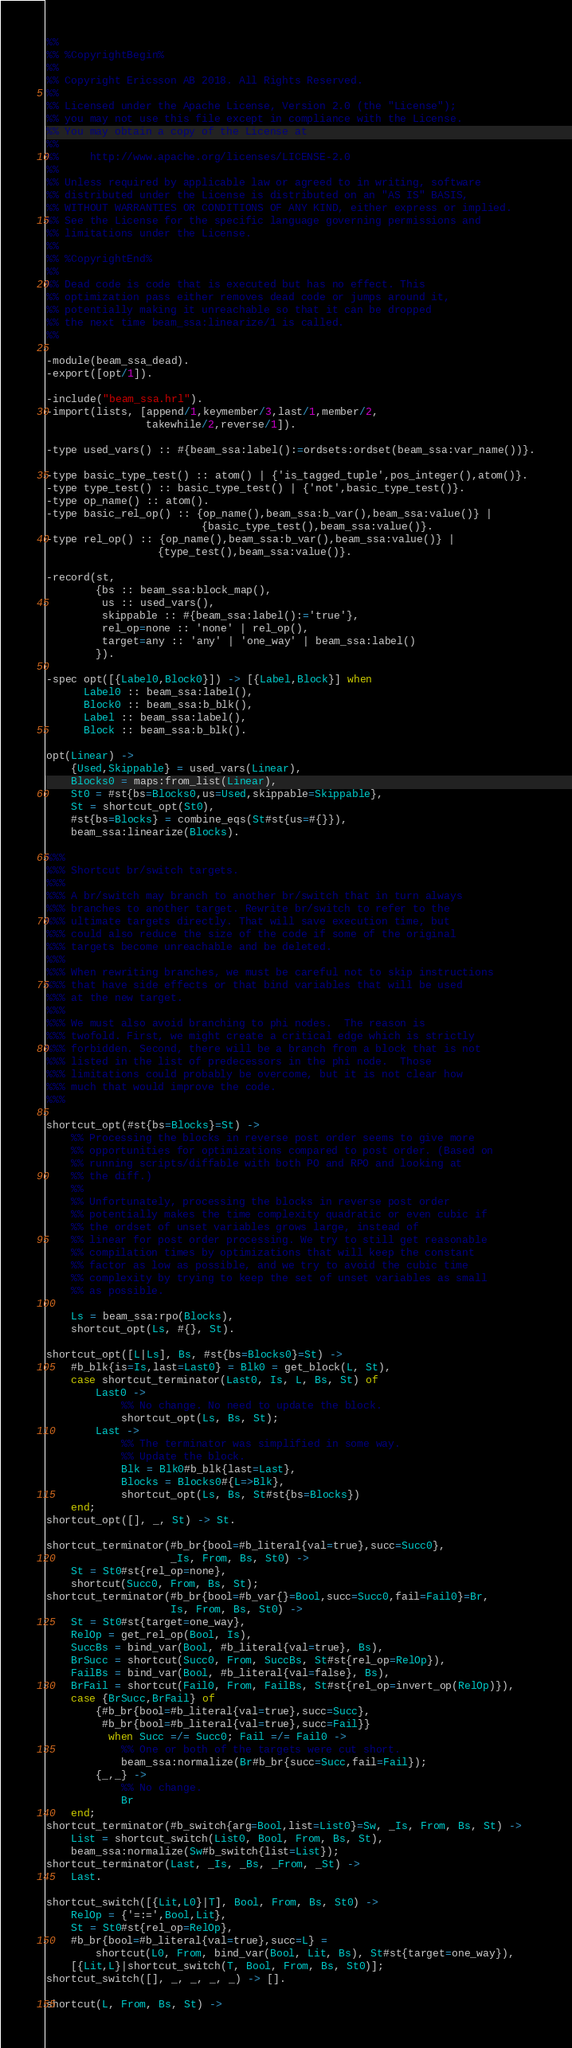<code> <loc_0><loc_0><loc_500><loc_500><_Erlang_>%%
%% %CopyrightBegin%
%%
%% Copyright Ericsson AB 2018. All Rights Reserved.
%%
%% Licensed under the Apache License, Version 2.0 (the "License");
%% you may not use this file except in compliance with the License.
%% You may obtain a copy of the License at
%%
%%     http://www.apache.org/licenses/LICENSE-2.0
%%
%% Unless required by applicable law or agreed to in writing, software
%% distributed under the License is distributed on an "AS IS" BASIS,
%% WITHOUT WARRANTIES OR CONDITIONS OF ANY KIND, either express or implied.
%% See the License for the specific language governing permissions and
%% limitations under the License.
%%
%% %CopyrightEnd%
%%
%% Dead code is code that is executed but has no effect. This
%% optimization pass either removes dead code or jumps around it,
%% potentially making it unreachable so that it can be dropped
%% the next time beam_ssa:linearize/1 is called.
%%

-module(beam_ssa_dead).
-export([opt/1]).

-include("beam_ssa.hrl").
-import(lists, [append/1,keymember/3,last/1,member/2,
                takewhile/2,reverse/1]).

-type used_vars() :: #{beam_ssa:label():=ordsets:ordset(beam_ssa:var_name())}.

-type basic_type_test() :: atom() | {'is_tagged_tuple',pos_integer(),atom()}.
-type type_test() :: basic_type_test() | {'not',basic_type_test()}.
-type op_name() :: atom().
-type basic_rel_op() :: {op_name(),beam_ssa:b_var(),beam_ssa:value()} |
                         {basic_type_test(),beam_ssa:value()}.
-type rel_op() :: {op_name(),beam_ssa:b_var(),beam_ssa:value()} |
                  {type_test(),beam_ssa:value()}.

-record(st,
        {bs :: beam_ssa:block_map(),
         us :: used_vars(),
         skippable :: #{beam_ssa:label():='true'},
         rel_op=none :: 'none' | rel_op(),
         target=any :: 'any' | 'one_way' | beam_ssa:label()
        }).

-spec opt([{Label0,Block0}]) -> [{Label,Block}] when
      Label0 :: beam_ssa:label(),
      Block0 :: beam_ssa:b_blk(),
      Label :: beam_ssa:label(),
      Block :: beam_ssa:b_blk().

opt(Linear) ->
    {Used,Skippable} = used_vars(Linear),
    Blocks0 = maps:from_list(Linear),
    St0 = #st{bs=Blocks0,us=Used,skippable=Skippable},
    St = shortcut_opt(St0),
    #st{bs=Blocks} = combine_eqs(St#st{us=#{}}),
    beam_ssa:linearize(Blocks).

%%%
%%% Shortcut br/switch targets.
%%%
%%% A br/switch may branch to another br/switch that in turn always
%%% branches to another target. Rewrite br/switch to refer to the
%%% ultimate targets directly. That will save execution time, but
%%% could also reduce the size of the code if some of the original
%%% targets become unreachable and be deleted.
%%%
%%% When rewriting branches, we must be careful not to skip instructions
%%% that have side effects or that bind variables that will be used
%%% at the new target.
%%%
%%% We must also avoid branching to phi nodes.  The reason is
%%% twofold. First, we might create a critical edge which is strictly
%%% forbidden. Second, there will be a branch from a block that is not
%%% listed in the list of predecessors in the phi node.  Those
%%% limitations could probably be overcome, but it is not clear how
%%% much that would improve the code.
%%%

shortcut_opt(#st{bs=Blocks}=St) ->
    %% Processing the blocks in reverse post order seems to give more
    %% opportunities for optimizations compared to post order. (Based on
    %% running scripts/diffable with both PO and RPO and looking at
    %% the diff.)
    %%
    %% Unfortunately, processing the blocks in reverse post order
    %% potentially makes the time complexity quadratic or even cubic if
    %% the ordset of unset variables grows large, instead of
    %% linear for post order processing. We try to still get reasonable
    %% compilation times by optimizations that will keep the constant
    %% factor as low as possible, and we try to avoid the cubic time
    %% complexity by trying to keep the set of unset variables as small
    %% as possible.

    Ls = beam_ssa:rpo(Blocks),
    shortcut_opt(Ls, #{}, St).

shortcut_opt([L|Ls], Bs, #st{bs=Blocks0}=St) ->
    #b_blk{is=Is,last=Last0} = Blk0 = get_block(L, St),
    case shortcut_terminator(Last0, Is, L, Bs, St) of
        Last0 ->
            %% No change. No need to update the block.
            shortcut_opt(Ls, Bs, St);
        Last ->
            %% The terminator was simplified in some way.
            %% Update the block.
            Blk = Blk0#b_blk{last=Last},
            Blocks = Blocks0#{L=>Blk},
            shortcut_opt(Ls, Bs, St#st{bs=Blocks})
    end;
shortcut_opt([], _, St) -> St.

shortcut_terminator(#b_br{bool=#b_literal{val=true},succ=Succ0},
                    _Is, From, Bs, St0) ->
    St = St0#st{rel_op=none},
    shortcut(Succ0, From, Bs, St);
shortcut_terminator(#b_br{bool=#b_var{}=Bool,succ=Succ0,fail=Fail0}=Br,
                    Is, From, Bs, St0) ->
    St = St0#st{target=one_way},
    RelOp = get_rel_op(Bool, Is),
    SuccBs = bind_var(Bool, #b_literal{val=true}, Bs),
    BrSucc = shortcut(Succ0, From, SuccBs, St#st{rel_op=RelOp}),
    FailBs = bind_var(Bool, #b_literal{val=false}, Bs),
    BrFail = shortcut(Fail0, From, FailBs, St#st{rel_op=invert_op(RelOp)}),
    case {BrSucc,BrFail} of
        {#b_br{bool=#b_literal{val=true},succ=Succ},
         #b_br{bool=#b_literal{val=true},succ=Fail}}
          when Succ =/= Succ0; Fail =/= Fail0 ->
            %% One or both of the targets were cut short.
            beam_ssa:normalize(Br#b_br{succ=Succ,fail=Fail});
        {_,_} ->
            %% No change.
            Br
    end;
shortcut_terminator(#b_switch{arg=Bool,list=List0}=Sw, _Is, From, Bs, St) ->
    List = shortcut_switch(List0, Bool, From, Bs, St),
    beam_ssa:normalize(Sw#b_switch{list=List});
shortcut_terminator(Last, _Is, _Bs, _From, _St) ->
    Last.

shortcut_switch([{Lit,L0}|T], Bool, From, Bs, St0) ->
    RelOp = {'=:=',Bool,Lit},
    St = St0#st{rel_op=RelOp},
    #b_br{bool=#b_literal{val=true},succ=L} =
        shortcut(L0, From, bind_var(Bool, Lit, Bs), St#st{target=one_way}),
    [{Lit,L}|shortcut_switch(T, Bool, From, Bs, St0)];
shortcut_switch([], _, _, _, _) -> [].

shortcut(L, From, Bs, St) -></code> 